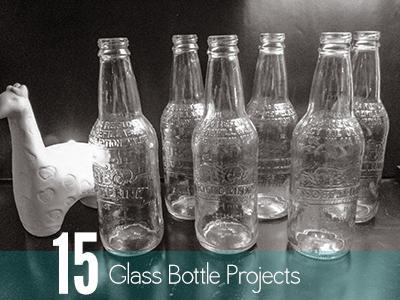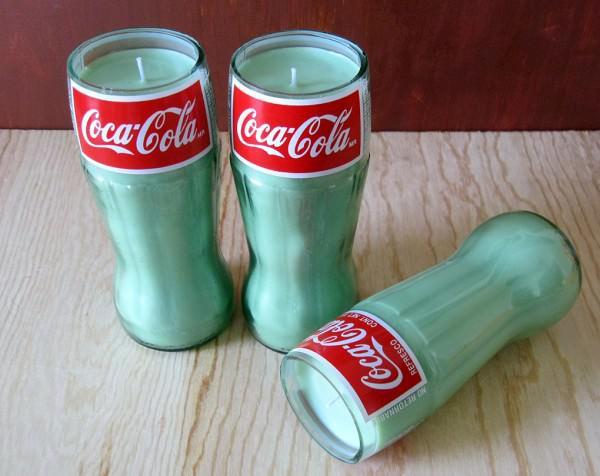The first image is the image on the left, the second image is the image on the right. For the images shown, is this caption "One image includes at least one candle with a wick in an upright glass soda bottle with a red label and its neck cut off." true? Answer yes or no. Yes. The first image is the image on the left, the second image is the image on the right. Evaluate the accuracy of this statement regarding the images: "The left and right image contains the same number of glass containers shaped like a bottle.". Is it true? Answer yes or no. No. 